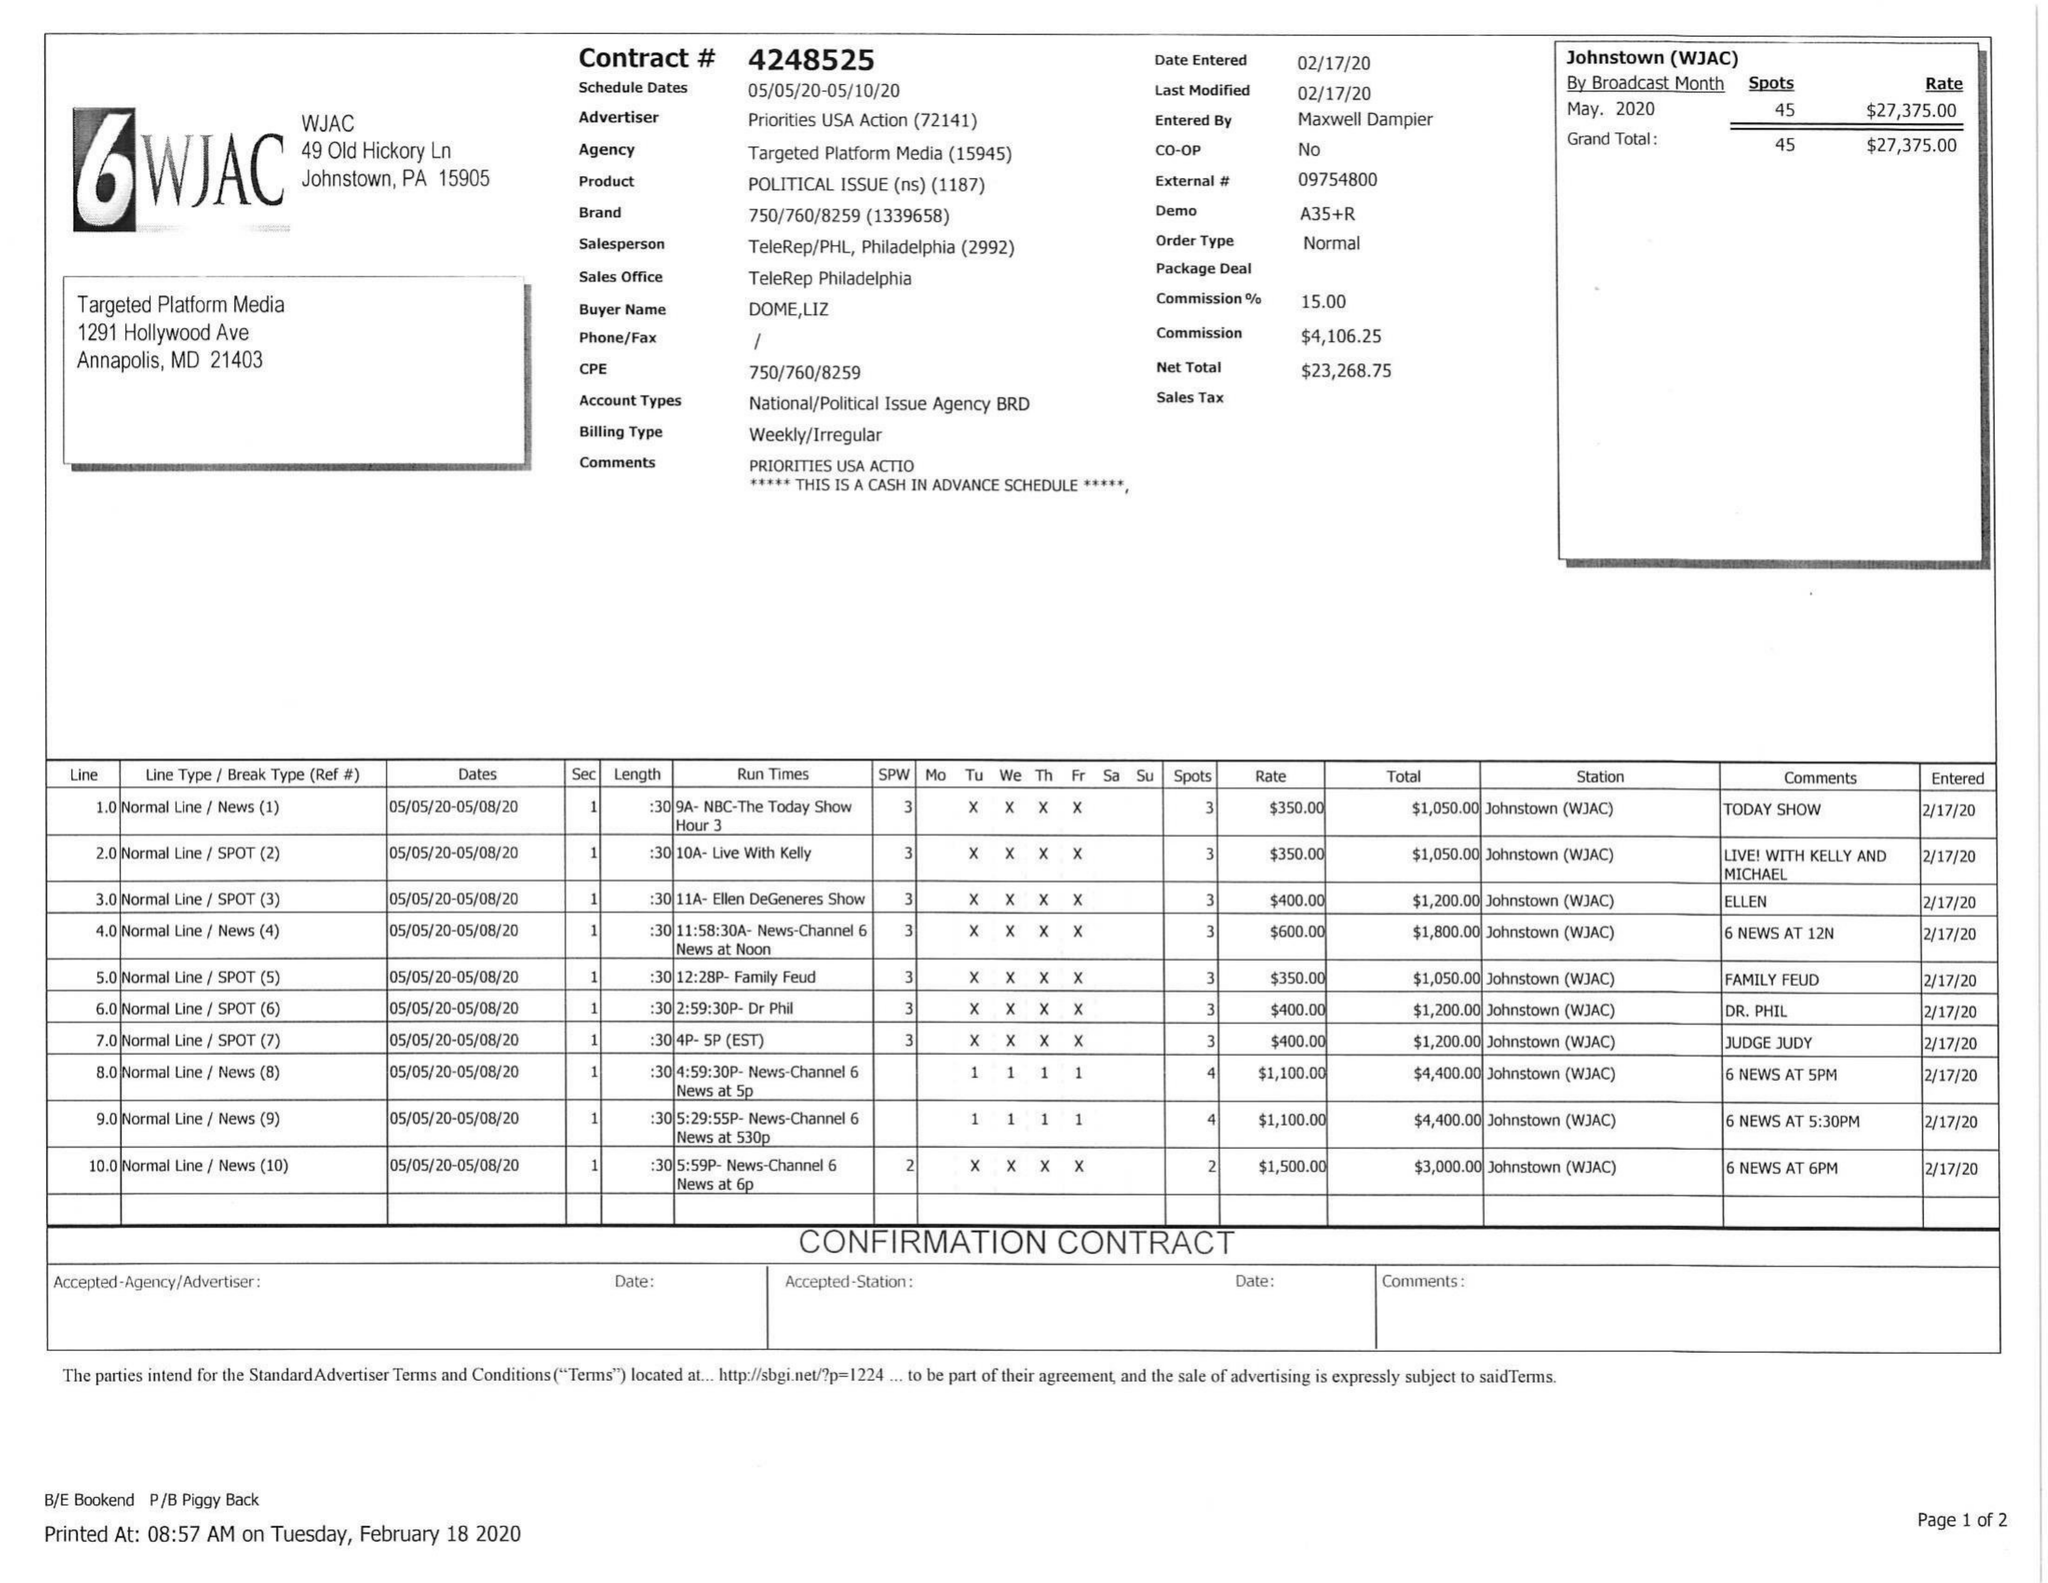What is the value for the flight_to?
Answer the question using a single word or phrase. 05/10/20 